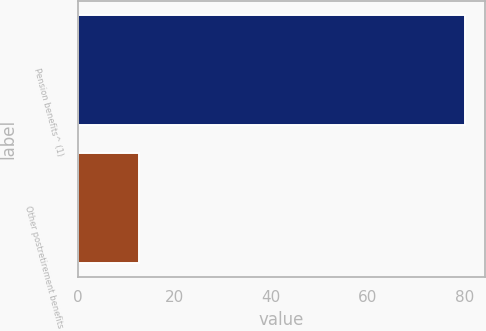Convert chart. <chart><loc_0><loc_0><loc_500><loc_500><bar_chart><fcel>Pension benefits^ (1)<fcel>Other postretirement benefits<nl><fcel>80.2<fcel>12.7<nl></chart> 